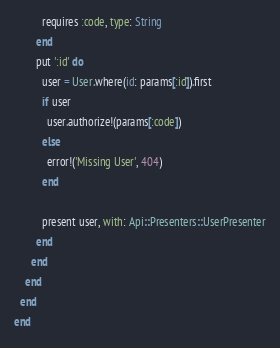<code> <loc_0><loc_0><loc_500><loc_500><_Ruby_>          requires :code, type: String
        end
        put ':id' do
          user = User.where(id: params[:id]).first
          if user
            user.authorize!(params[:code])
          else
            error!('Missing User', 404)
          end

          present user, with: Api::Presenters::UserPresenter
        end
      end
    end
  end
end
</code> 